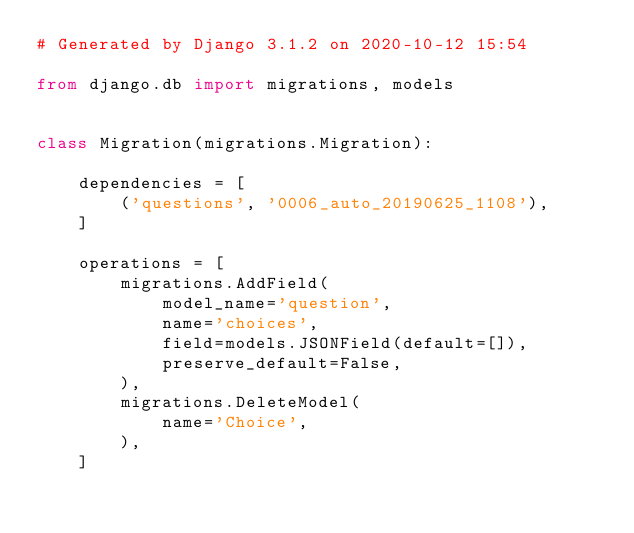<code> <loc_0><loc_0><loc_500><loc_500><_Python_># Generated by Django 3.1.2 on 2020-10-12 15:54

from django.db import migrations, models


class Migration(migrations.Migration):

    dependencies = [
        ('questions', '0006_auto_20190625_1108'),
    ]

    operations = [
        migrations.AddField(
            model_name='question',
            name='choices',
            field=models.JSONField(default=[]),
            preserve_default=False,
        ),
        migrations.DeleteModel(
            name='Choice',
        ),
    ]
</code> 